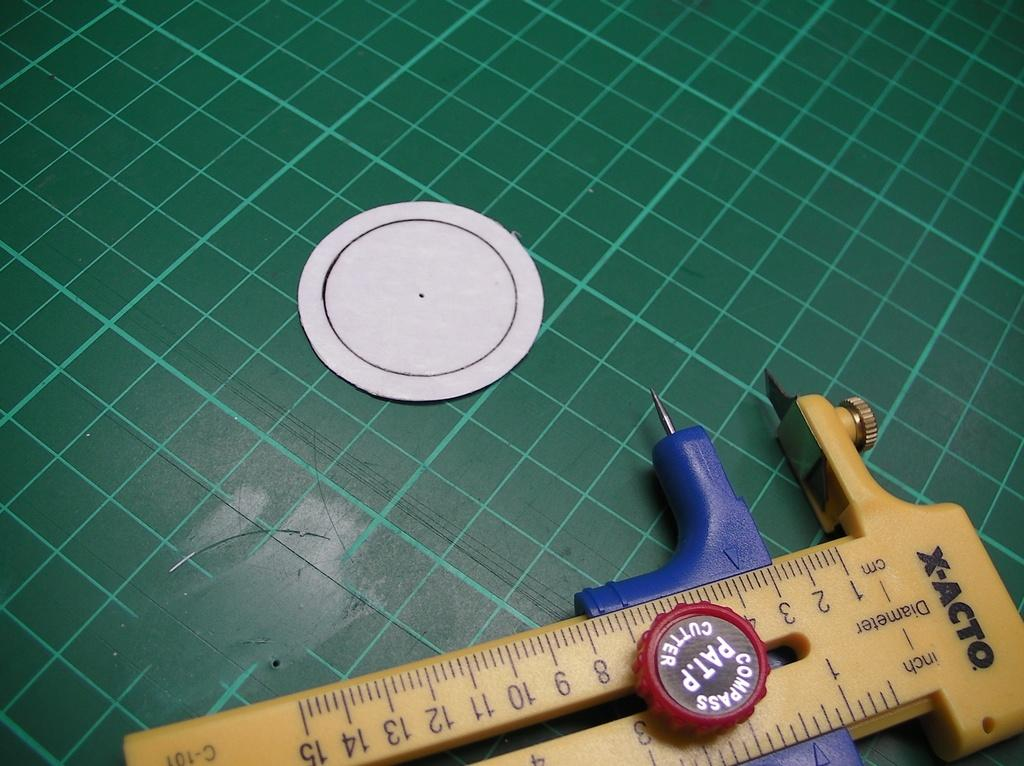<image>
Render a clear and concise summary of the photo. A compass Pat.P cutter made by X-Acto, used to cut circles, is sitting on a green piece of plastic. 